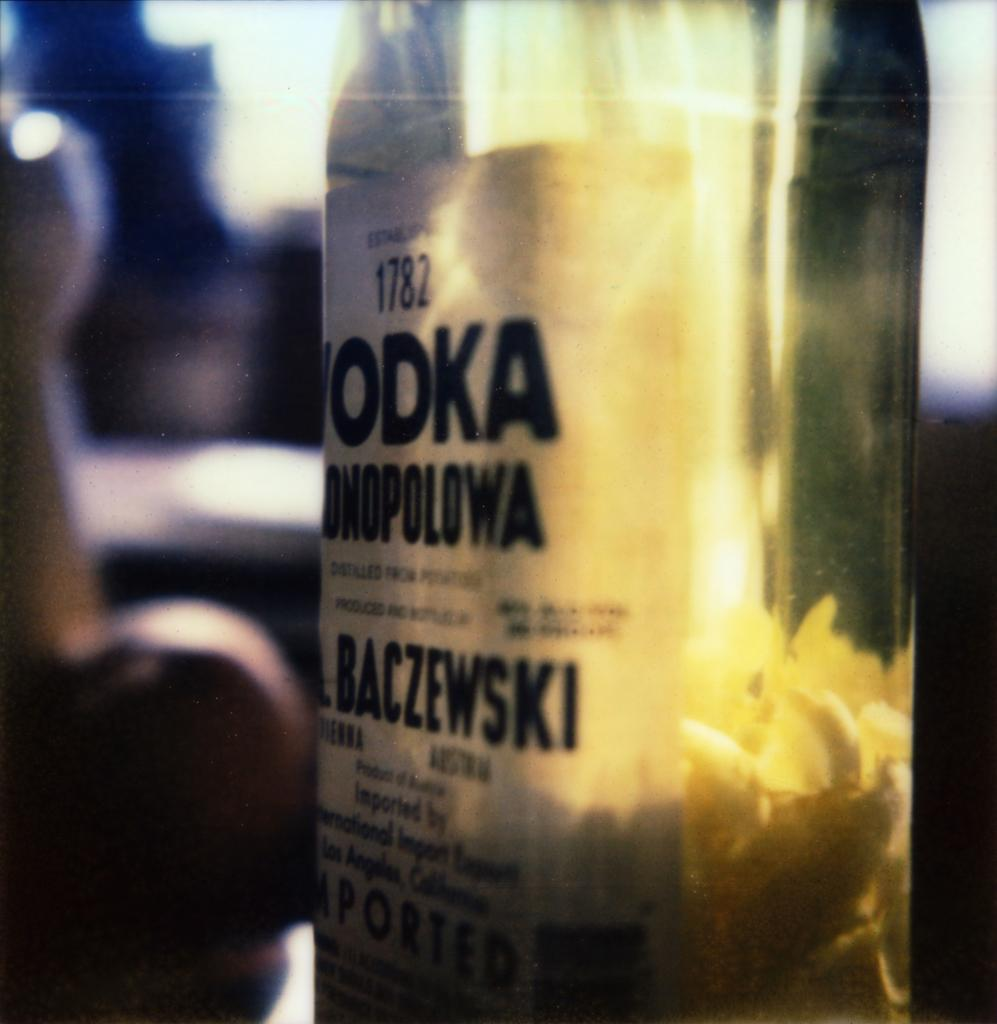What object is present in the image? There is a bottle in the image. What is on the bottle? The bottle has a sticker on it, and there are food items on the bottle. How is the background of the image depicted? The background of the bottle is blurred. How many times does the earth appear in the image? The image does not depict the earth; it features a bottle with a sticker and food items. 